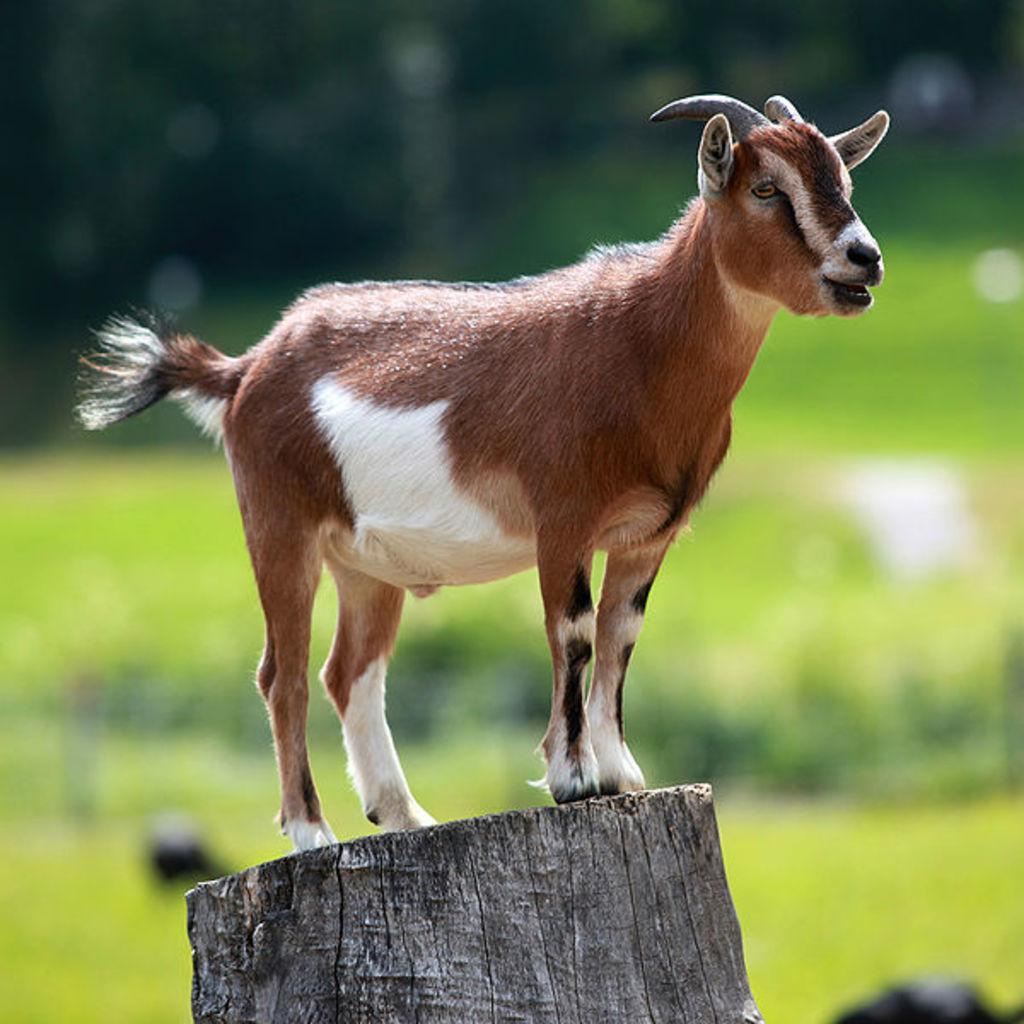What animal is present in the image? There is a goat in the image. What is the goat doing in the image? The goat is standing on a tree trunk. What color is the goat in the image? The goat is brown in color. Is the goat offering a sacrifice to the volcano in the image? There is no volcano present in the image, and the goat is not performing any actions related to offering a sacrifice. 